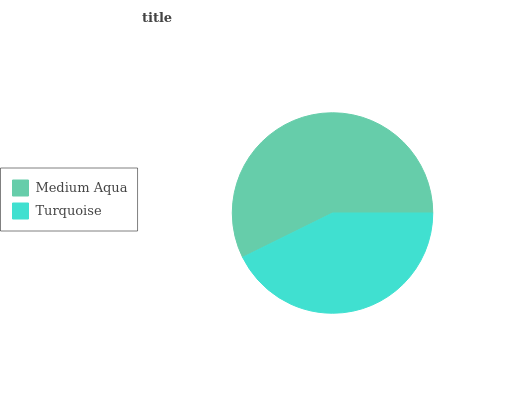Is Turquoise the minimum?
Answer yes or no. Yes. Is Medium Aqua the maximum?
Answer yes or no. Yes. Is Turquoise the maximum?
Answer yes or no. No. Is Medium Aqua greater than Turquoise?
Answer yes or no. Yes. Is Turquoise less than Medium Aqua?
Answer yes or no. Yes. Is Turquoise greater than Medium Aqua?
Answer yes or no. No. Is Medium Aqua less than Turquoise?
Answer yes or no. No. Is Medium Aqua the high median?
Answer yes or no. Yes. Is Turquoise the low median?
Answer yes or no. Yes. Is Turquoise the high median?
Answer yes or no. No. Is Medium Aqua the low median?
Answer yes or no. No. 